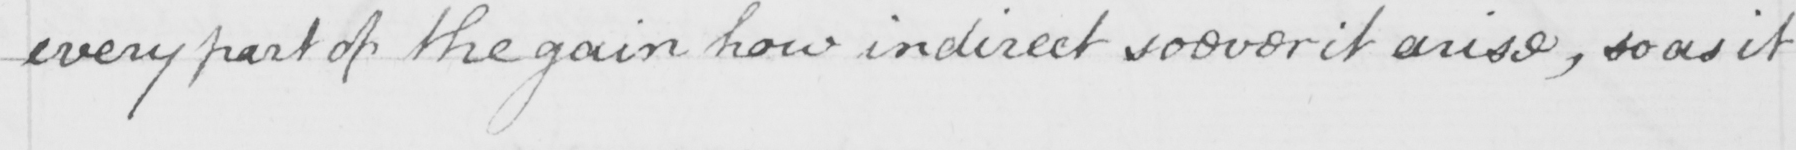Transcribe the text shown in this historical manuscript line. every part of the gain how indirect soever it arise , so as it 